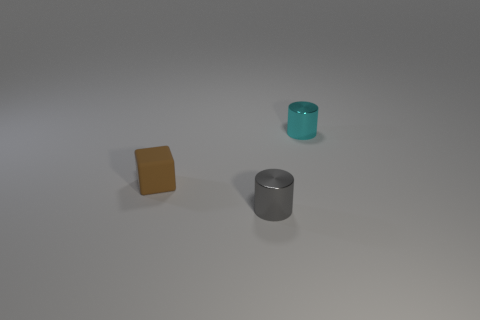What could these objects be used for? The cube could serve as a paperweight or a decorative element due to its matte texture and interesting color. The teal cylindrical container might be a small holder for pens or tools, while the metallic grey cylinder could be a container or perhaps a minimalist vase for holding slender flowers or decorative twigs. 